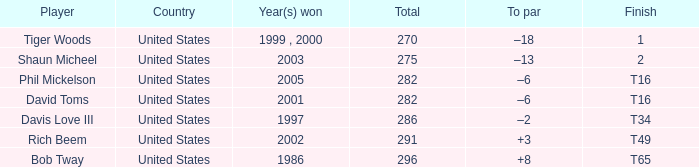What is the to par number of the person who won in 2003? –13. 